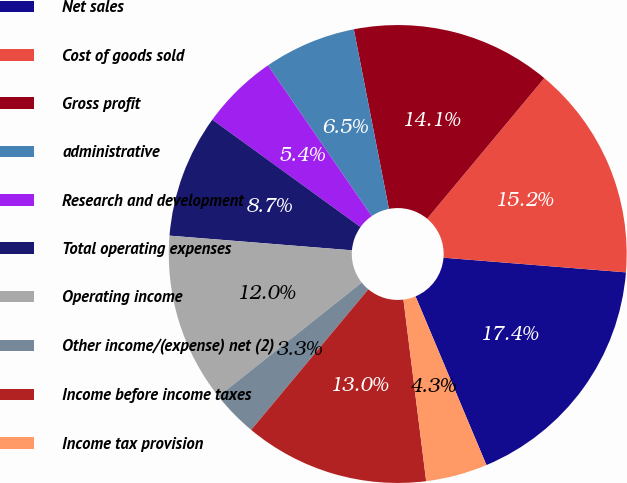<chart> <loc_0><loc_0><loc_500><loc_500><pie_chart><fcel>Net sales<fcel>Cost of goods sold<fcel>Gross profit<fcel>administrative<fcel>Research and development<fcel>Total operating expenses<fcel>Operating income<fcel>Other income/(expense) net (2)<fcel>Income before income taxes<fcel>Income tax provision<nl><fcel>17.39%<fcel>15.22%<fcel>14.13%<fcel>6.52%<fcel>5.43%<fcel>8.7%<fcel>11.96%<fcel>3.26%<fcel>13.04%<fcel>4.35%<nl></chart> 